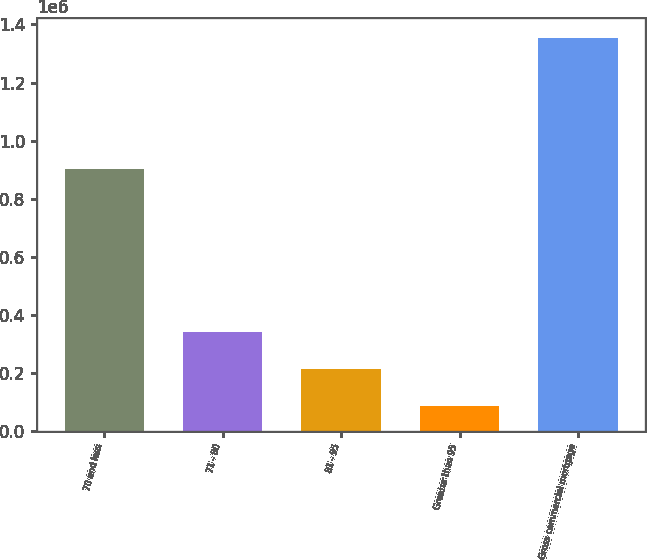Convert chart to OTSL. <chart><loc_0><loc_0><loc_500><loc_500><bar_chart><fcel>70 and less<fcel>71 - 80<fcel>81 - 95<fcel>Greater than 95<fcel>Gross commercial mortgage<nl><fcel>902271<fcel>340165<fcel>213461<fcel>86756<fcel>1.3538e+06<nl></chart> 